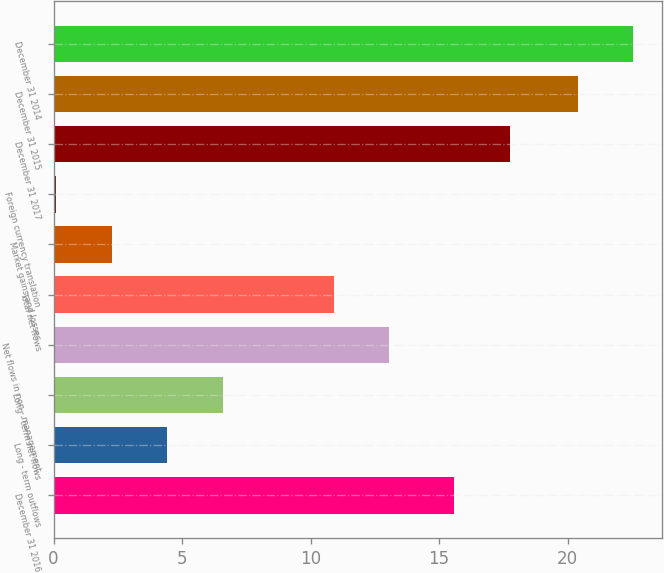Convert chart to OTSL. <chart><loc_0><loc_0><loc_500><loc_500><bar_chart><fcel>December 31 2016<fcel>Long - term outflows<fcel>Long - term net flows<fcel>Net flows in non - management<fcel>Total net flows<fcel>Market gains and losses<fcel>Foreign currency translation<fcel>December 31 2017<fcel>December 31 2015<fcel>December 31 2014<nl><fcel>15.6<fcel>4.42<fcel>6.58<fcel>13.06<fcel>10.9<fcel>2.26<fcel>0.1<fcel>17.76<fcel>20.4<fcel>22.56<nl></chart> 